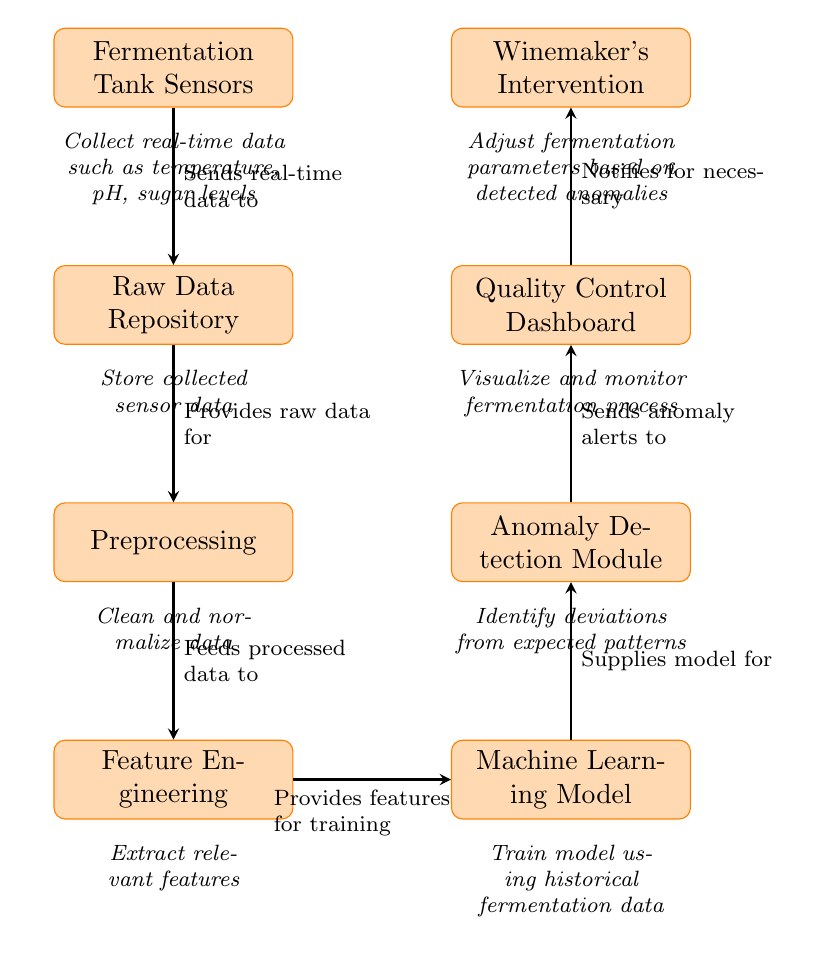What is the first step in the diagram? The first step in the diagram is represented by the node "Fermentation Tank Sensors", which collects real-time data.
Answer: Fermentation Tank Sensors How many total nodes are in the diagram? Counting all the processes from the first node "Fermentation Tank Sensors" to the last node "Winemaker's Intervention", there are a total of 8 nodes.
Answer: 8 What is the output of the "Anomaly Detection Module"? The "Anomaly Detection Module" sends anomaly alerts to the "Quality Control Dashboard", which serves as its output.
Answer: Sends anomaly alerts to Quality Control Dashboard Which node describes the preprocessing of raw data? The node that describes this process is "Preprocessing", which involves cleaning and normalizing data.
Answer: Preprocessing What is the function of the "Quality Control Dashboard"? The function of the "Quality Control Dashboard" is to visualize and monitor the fermentation process.
Answer: Visualize and monitor fermentation process What data source feeds into the "Preprocessing" step? The "Preprocessing" step receives raw data from the "Raw Data Repository".
Answer: Raw Data Repository What happens after the "Anomaly Detection Module"? After the "Anomaly Detection Module", the next step is the "Quality Control Dashboard", which gets the alerts for monitoring.
Answer: Quality Control Dashboard Which node is responsible for adjusting fermentation parameters? The node responsible for this is "Winemaker's Intervention", which takes actions based on detected anomalies.
Answer: Winemaker's Intervention What does "Feature Engineering" provide to the "Machine Learning Model"? "Feature Engineering" provides relevant features for training the "Machine Learning Model".
Answer: Relevant features for training 